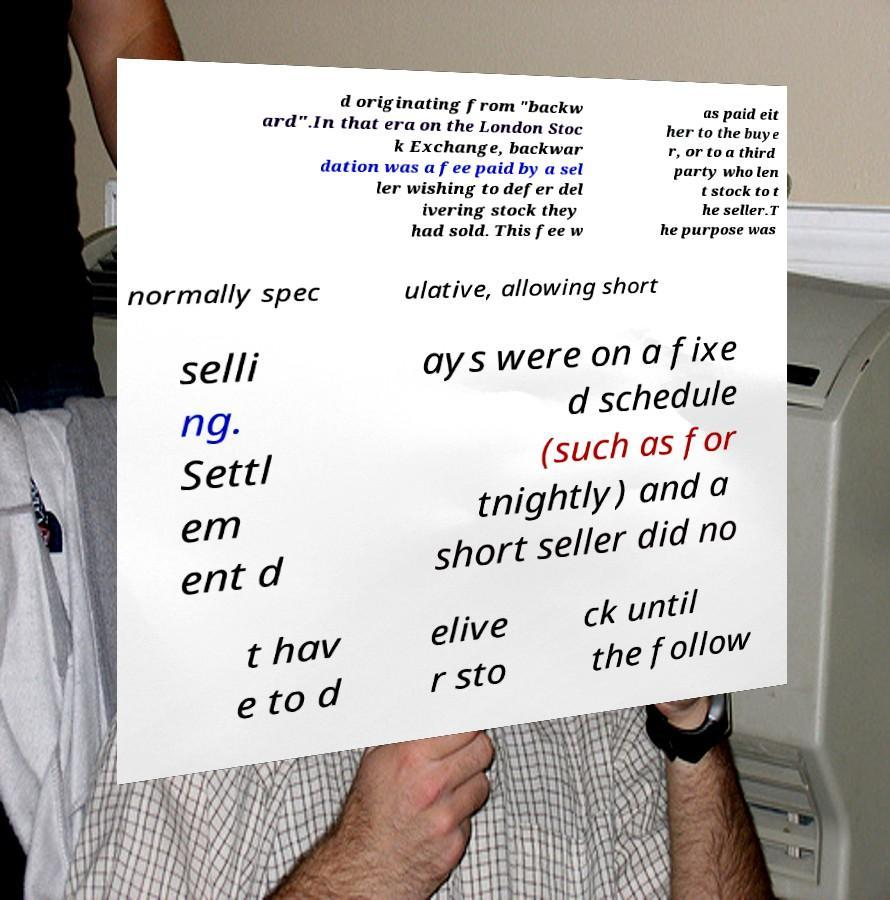For documentation purposes, I need the text within this image transcribed. Could you provide that? d originating from "backw ard".In that era on the London Stoc k Exchange, backwar dation was a fee paid by a sel ler wishing to defer del ivering stock they had sold. This fee w as paid eit her to the buye r, or to a third party who len t stock to t he seller.T he purpose was normally spec ulative, allowing short selli ng. Settl em ent d ays were on a fixe d schedule (such as for tnightly) and a short seller did no t hav e to d elive r sto ck until the follow 